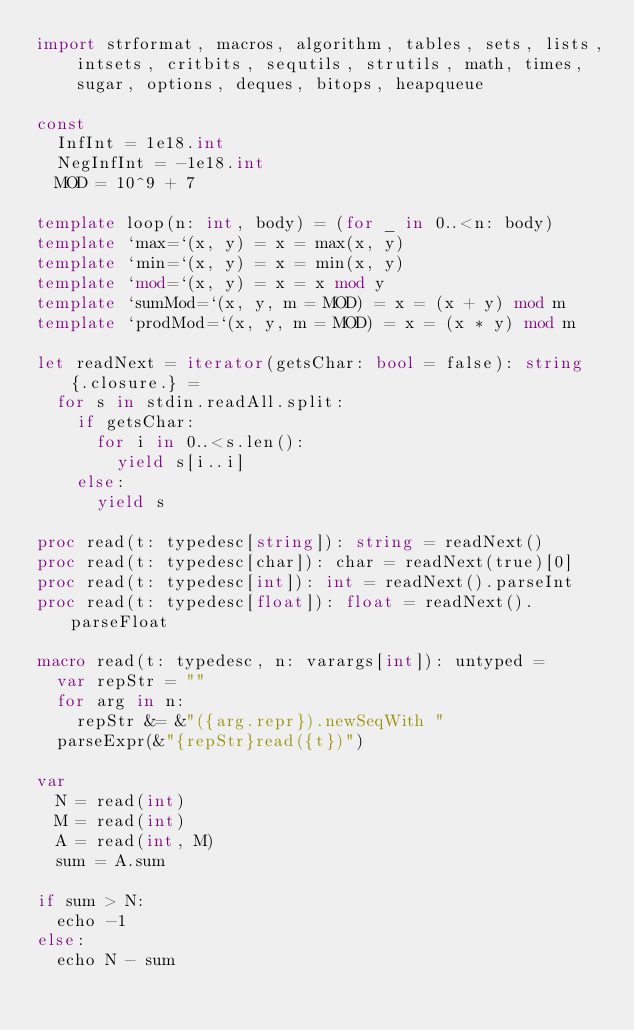Convert code to text. <code><loc_0><loc_0><loc_500><loc_500><_Nim_>import strformat, macros, algorithm, tables, sets, lists,
    intsets, critbits, sequtils, strutils, math, times,
    sugar, options, deques, bitops, heapqueue

const
  InfInt = 1e18.int
  NegInfInt = -1e18.int
  MOD = 10^9 + 7

template loop(n: int, body) = (for _ in 0..<n: body)
template `max=`(x, y) = x = max(x, y)
template `min=`(x, y) = x = min(x, y)
template `mod=`(x, y) = x = x mod y
template `sumMod=`(x, y, m = MOD) = x = (x + y) mod m
template `prodMod=`(x, y, m = MOD) = x = (x * y) mod m

let readNext = iterator(getsChar: bool = false): string {.closure.} =
  for s in stdin.readAll.split:
    if getsChar:
      for i in 0..<s.len():
        yield s[i..i]
    else:
      yield s

proc read(t: typedesc[string]): string = readNext()
proc read(t: typedesc[char]): char = readNext(true)[0]
proc read(t: typedesc[int]): int = readNext().parseInt
proc read(t: typedesc[float]): float = readNext().parseFloat

macro read(t: typedesc, n: varargs[int]): untyped =
  var repStr = ""
  for arg in n:
    repStr &= &"({arg.repr}).newSeqWith "
  parseExpr(&"{repStr}read({t})")

var
  N = read(int)
  M = read(int)
  A = read(int, M)
  sum = A.sum

if sum > N:
  echo -1
else:
  echo N - sum
</code> 